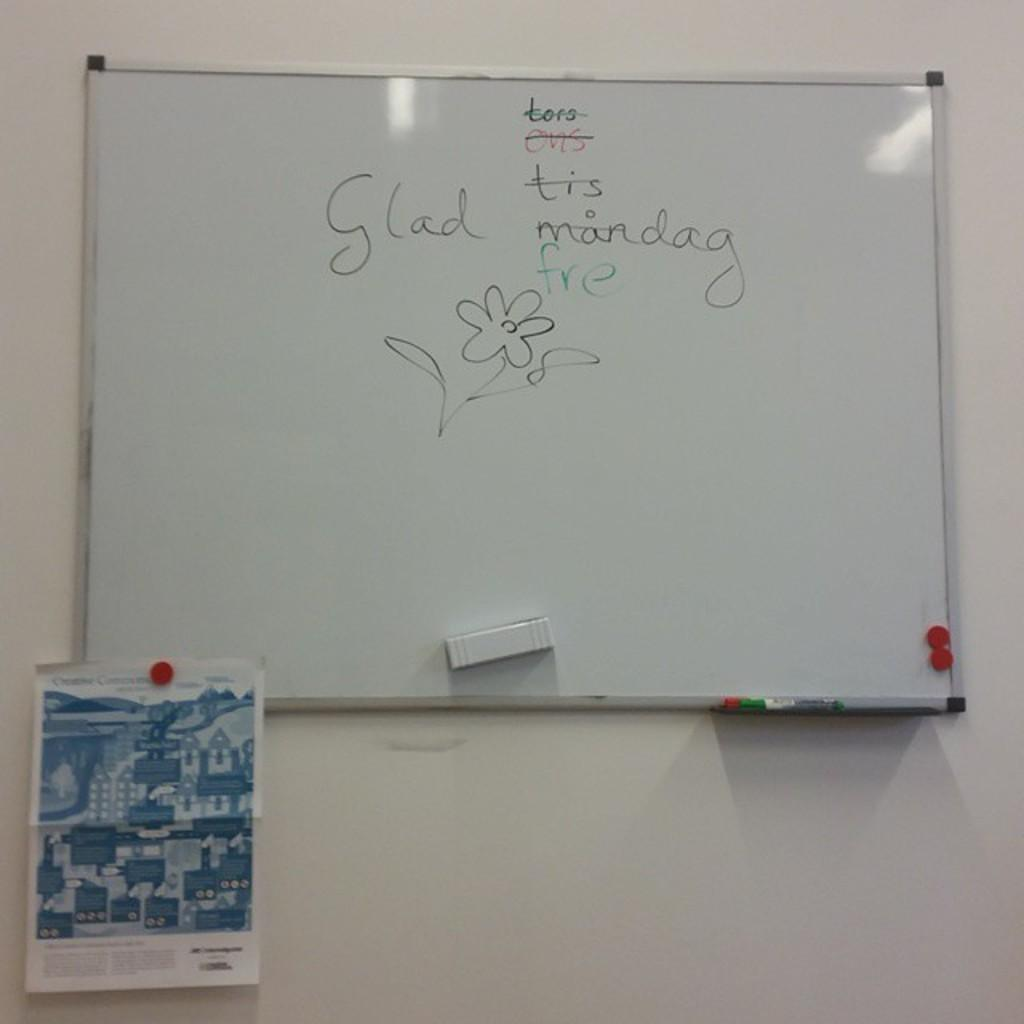Provide a one-sentence caption for the provided image. A white board on the wall with writing that says "Glad freday". 